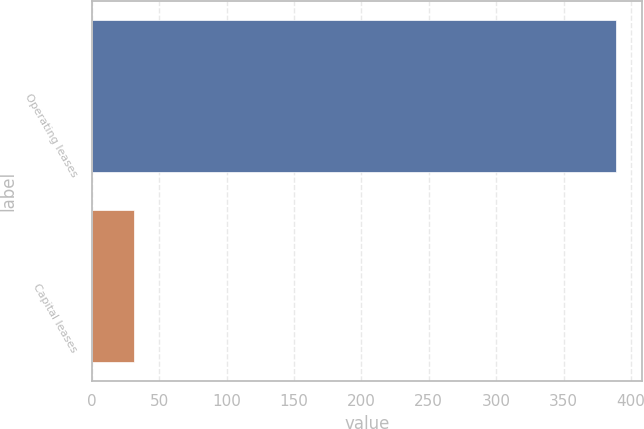<chart> <loc_0><loc_0><loc_500><loc_500><bar_chart><fcel>Operating leases<fcel>Capital leases<nl><fcel>389<fcel>31<nl></chart> 